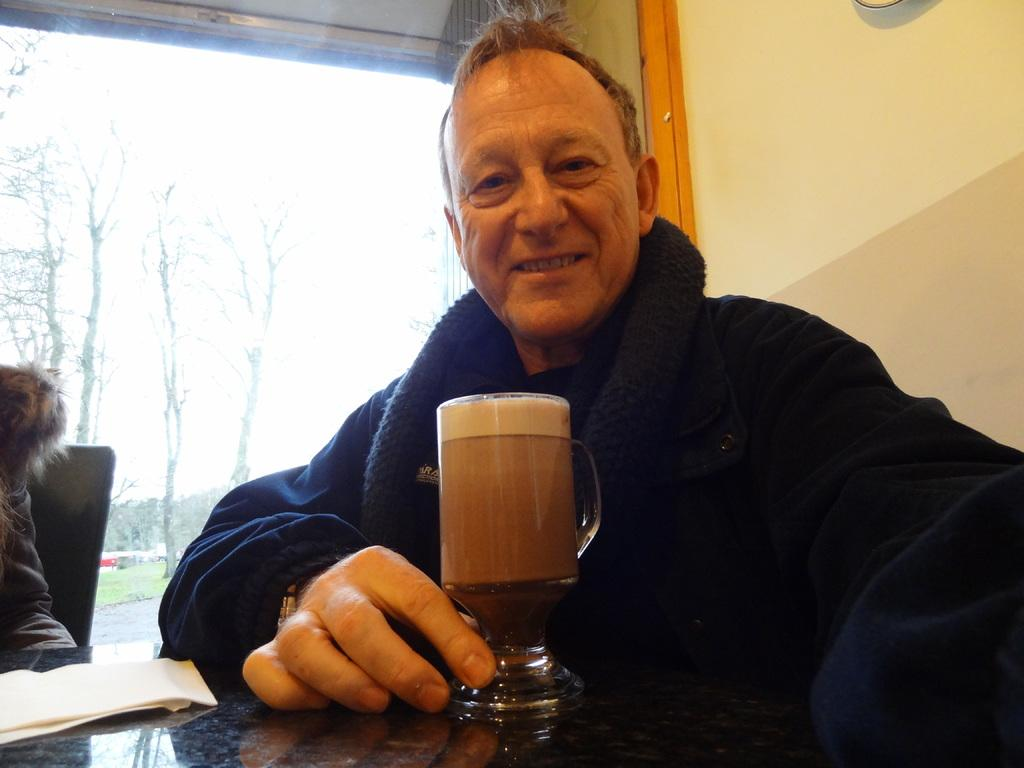Who is present in the image? There is a man in the image. What is the man holding in front of him? The man has a beer glass in front of him. Where is the image set? The setting appears to be inside a room. What can be seen outside the room? Trees are visible outside the room. What type of flooring is present outside the room? Grass is present on the floor outside the room. What direction is the market located in relation to the room in the image? There is no mention of a market in the image, so it cannot be determined which direction it might be located. 